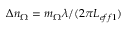Convert formula to latex. <formula><loc_0><loc_0><loc_500><loc_500>\Delta n _ { \Omega } = m _ { \Omega } \lambda / ( 2 \pi L _ { e f f 1 } )</formula> 